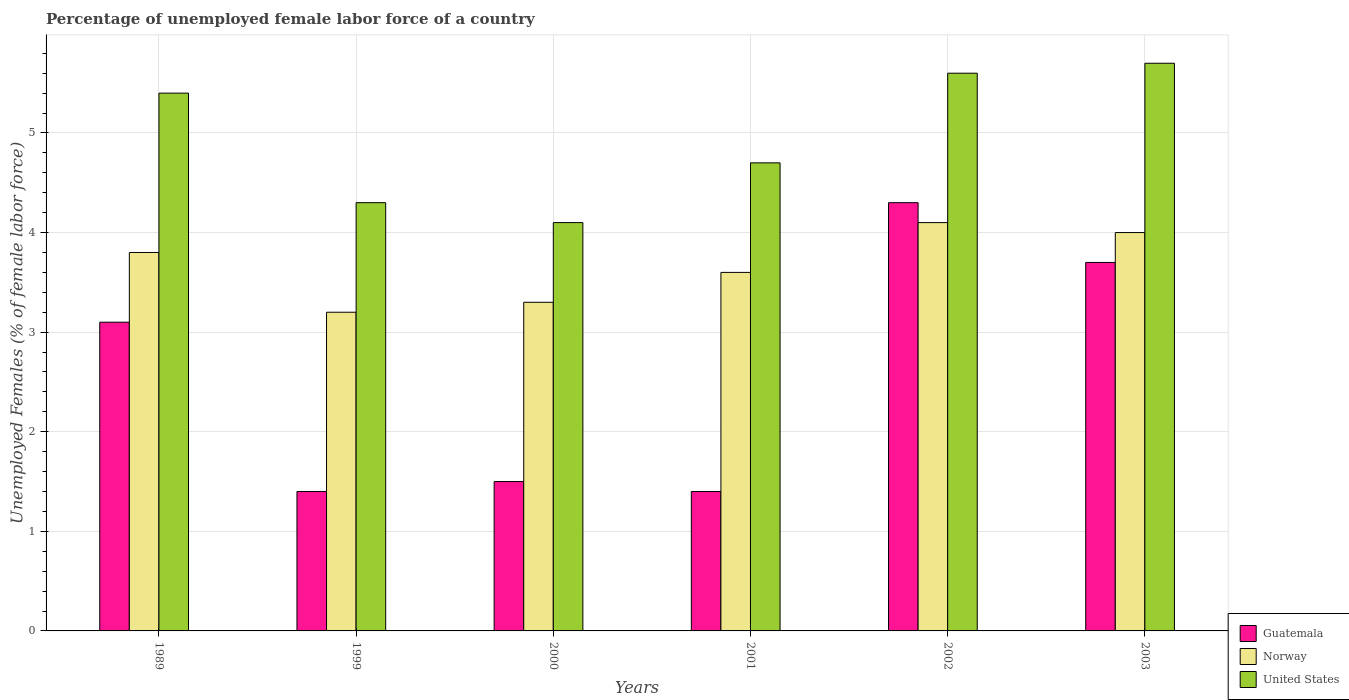How many different coloured bars are there?
Your response must be concise. 3. How many groups of bars are there?
Make the answer very short. 6. What is the percentage of unemployed female labor force in United States in 2003?
Ensure brevity in your answer.  5.7. Across all years, what is the maximum percentage of unemployed female labor force in United States?
Offer a terse response. 5.7. Across all years, what is the minimum percentage of unemployed female labor force in Guatemala?
Offer a very short reply. 1.4. In which year was the percentage of unemployed female labor force in Guatemala maximum?
Your response must be concise. 2002. What is the total percentage of unemployed female labor force in United States in the graph?
Ensure brevity in your answer.  29.8. What is the difference between the percentage of unemployed female labor force in Norway in 1989 and that in 2002?
Your response must be concise. -0.3. What is the difference between the percentage of unemployed female labor force in United States in 2001 and the percentage of unemployed female labor force in Guatemala in 1989?
Your answer should be compact. 1.6. What is the average percentage of unemployed female labor force in United States per year?
Provide a succinct answer. 4.97. In the year 1999, what is the difference between the percentage of unemployed female labor force in Norway and percentage of unemployed female labor force in United States?
Offer a terse response. -1.1. What is the ratio of the percentage of unemployed female labor force in Guatemala in 1989 to that in 2003?
Keep it short and to the point. 0.84. Is the difference between the percentage of unemployed female labor force in Norway in 2001 and 2002 greater than the difference between the percentage of unemployed female labor force in United States in 2001 and 2002?
Your answer should be very brief. Yes. What is the difference between the highest and the second highest percentage of unemployed female labor force in United States?
Make the answer very short. 0.1. What is the difference between the highest and the lowest percentage of unemployed female labor force in United States?
Offer a very short reply. 1.6. What does the 1st bar from the left in 2000 represents?
Offer a very short reply. Guatemala. What does the 3rd bar from the right in 1999 represents?
Provide a short and direct response. Guatemala. How many bars are there?
Keep it short and to the point. 18. Are all the bars in the graph horizontal?
Keep it short and to the point. No. How many years are there in the graph?
Keep it short and to the point. 6. What is the difference between two consecutive major ticks on the Y-axis?
Keep it short and to the point. 1. Does the graph contain grids?
Provide a short and direct response. Yes. Where does the legend appear in the graph?
Make the answer very short. Bottom right. How many legend labels are there?
Give a very brief answer. 3. What is the title of the graph?
Offer a very short reply. Percentage of unemployed female labor force of a country. What is the label or title of the Y-axis?
Give a very brief answer. Unemployed Females (% of female labor force). What is the Unemployed Females (% of female labor force) in Guatemala in 1989?
Provide a short and direct response. 3.1. What is the Unemployed Females (% of female labor force) in Norway in 1989?
Provide a short and direct response. 3.8. What is the Unemployed Females (% of female labor force) in United States in 1989?
Offer a very short reply. 5.4. What is the Unemployed Females (% of female labor force) of Guatemala in 1999?
Your response must be concise. 1.4. What is the Unemployed Females (% of female labor force) of Norway in 1999?
Provide a succinct answer. 3.2. What is the Unemployed Females (% of female labor force) of United States in 1999?
Keep it short and to the point. 4.3. What is the Unemployed Females (% of female labor force) in Guatemala in 2000?
Provide a short and direct response. 1.5. What is the Unemployed Females (% of female labor force) of Norway in 2000?
Your answer should be compact. 3.3. What is the Unemployed Females (% of female labor force) in United States in 2000?
Give a very brief answer. 4.1. What is the Unemployed Females (% of female labor force) of Guatemala in 2001?
Provide a short and direct response. 1.4. What is the Unemployed Females (% of female labor force) in Norway in 2001?
Your answer should be very brief. 3.6. What is the Unemployed Females (% of female labor force) of United States in 2001?
Your answer should be very brief. 4.7. What is the Unemployed Females (% of female labor force) of Guatemala in 2002?
Offer a very short reply. 4.3. What is the Unemployed Females (% of female labor force) of Norway in 2002?
Provide a succinct answer. 4.1. What is the Unemployed Females (% of female labor force) of United States in 2002?
Provide a succinct answer. 5.6. What is the Unemployed Females (% of female labor force) in Guatemala in 2003?
Your response must be concise. 3.7. What is the Unemployed Females (% of female labor force) of United States in 2003?
Offer a terse response. 5.7. Across all years, what is the maximum Unemployed Females (% of female labor force) in Guatemala?
Keep it short and to the point. 4.3. Across all years, what is the maximum Unemployed Females (% of female labor force) in Norway?
Provide a short and direct response. 4.1. Across all years, what is the maximum Unemployed Females (% of female labor force) of United States?
Give a very brief answer. 5.7. Across all years, what is the minimum Unemployed Females (% of female labor force) of Guatemala?
Give a very brief answer. 1.4. Across all years, what is the minimum Unemployed Females (% of female labor force) in Norway?
Your response must be concise. 3.2. Across all years, what is the minimum Unemployed Females (% of female labor force) of United States?
Ensure brevity in your answer.  4.1. What is the total Unemployed Females (% of female labor force) of Guatemala in the graph?
Give a very brief answer. 15.4. What is the total Unemployed Females (% of female labor force) of United States in the graph?
Keep it short and to the point. 29.8. What is the difference between the Unemployed Females (% of female labor force) of United States in 1989 and that in 1999?
Provide a succinct answer. 1.1. What is the difference between the Unemployed Females (% of female labor force) of Norway in 1989 and that in 2001?
Your response must be concise. 0.2. What is the difference between the Unemployed Females (% of female labor force) in United States in 1989 and that in 2001?
Offer a terse response. 0.7. What is the difference between the Unemployed Females (% of female labor force) in Guatemala in 1989 and that in 2002?
Your answer should be very brief. -1.2. What is the difference between the Unemployed Females (% of female labor force) of Norway in 1989 and that in 2002?
Offer a very short reply. -0.3. What is the difference between the Unemployed Females (% of female labor force) of Guatemala in 1989 and that in 2003?
Offer a terse response. -0.6. What is the difference between the Unemployed Females (% of female labor force) in Norway in 1989 and that in 2003?
Your answer should be compact. -0.2. What is the difference between the Unemployed Females (% of female labor force) in Norway in 1999 and that in 2001?
Your response must be concise. -0.4. What is the difference between the Unemployed Females (% of female labor force) in United States in 1999 and that in 2001?
Your response must be concise. -0.4. What is the difference between the Unemployed Females (% of female labor force) of Guatemala in 1999 and that in 2002?
Make the answer very short. -2.9. What is the difference between the Unemployed Females (% of female labor force) in Norway in 1999 and that in 2002?
Keep it short and to the point. -0.9. What is the difference between the Unemployed Females (% of female labor force) of Guatemala in 1999 and that in 2003?
Provide a succinct answer. -2.3. What is the difference between the Unemployed Females (% of female labor force) in United States in 2000 and that in 2001?
Keep it short and to the point. -0.6. What is the difference between the Unemployed Females (% of female labor force) of United States in 2000 and that in 2002?
Your response must be concise. -1.5. What is the difference between the Unemployed Females (% of female labor force) of Norway in 2000 and that in 2003?
Keep it short and to the point. -0.7. What is the difference between the Unemployed Females (% of female labor force) in Guatemala in 2001 and that in 2002?
Your answer should be compact. -2.9. What is the difference between the Unemployed Females (% of female labor force) of Guatemala in 2001 and that in 2003?
Give a very brief answer. -2.3. What is the difference between the Unemployed Females (% of female labor force) of Norway in 2001 and that in 2003?
Make the answer very short. -0.4. What is the difference between the Unemployed Females (% of female labor force) in United States in 2001 and that in 2003?
Ensure brevity in your answer.  -1. What is the difference between the Unemployed Females (% of female labor force) of Guatemala in 1989 and the Unemployed Females (% of female labor force) of Norway in 1999?
Offer a terse response. -0.1. What is the difference between the Unemployed Females (% of female labor force) in Guatemala in 1989 and the Unemployed Females (% of female labor force) in Norway in 2000?
Your response must be concise. -0.2. What is the difference between the Unemployed Females (% of female labor force) in Guatemala in 1989 and the Unemployed Females (% of female labor force) in Norway in 2001?
Your answer should be very brief. -0.5. What is the difference between the Unemployed Females (% of female labor force) of Guatemala in 1989 and the Unemployed Females (% of female labor force) of United States in 2001?
Offer a terse response. -1.6. What is the difference between the Unemployed Females (% of female labor force) in Norway in 1989 and the Unemployed Females (% of female labor force) in United States in 2001?
Your response must be concise. -0.9. What is the difference between the Unemployed Females (% of female labor force) of Guatemala in 1989 and the Unemployed Females (% of female labor force) of Norway in 2002?
Your response must be concise. -1. What is the difference between the Unemployed Females (% of female labor force) in Norway in 1989 and the Unemployed Females (% of female labor force) in United States in 2002?
Offer a terse response. -1.8. What is the difference between the Unemployed Females (% of female labor force) of Norway in 1989 and the Unemployed Females (% of female labor force) of United States in 2003?
Your answer should be very brief. -1.9. What is the difference between the Unemployed Females (% of female labor force) in Guatemala in 1999 and the Unemployed Females (% of female labor force) in Norway in 2002?
Your answer should be compact. -2.7. What is the difference between the Unemployed Females (% of female labor force) in Norway in 1999 and the Unemployed Females (% of female labor force) in United States in 2002?
Keep it short and to the point. -2.4. What is the difference between the Unemployed Females (% of female labor force) in Guatemala in 1999 and the Unemployed Females (% of female labor force) in United States in 2003?
Ensure brevity in your answer.  -4.3. What is the difference between the Unemployed Females (% of female labor force) of Norway in 1999 and the Unemployed Females (% of female labor force) of United States in 2003?
Provide a short and direct response. -2.5. What is the difference between the Unemployed Females (% of female labor force) in Guatemala in 2000 and the Unemployed Females (% of female labor force) in United States in 2001?
Your answer should be compact. -3.2. What is the difference between the Unemployed Females (% of female labor force) of Norway in 2000 and the Unemployed Females (% of female labor force) of United States in 2001?
Provide a succinct answer. -1.4. What is the difference between the Unemployed Females (% of female labor force) of Guatemala in 2000 and the Unemployed Females (% of female labor force) of Norway in 2002?
Provide a short and direct response. -2.6. What is the difference between the Unemployed Females (% of female labor force) in Norway in 2000 and the Unemployed Females (% of female labor force) in United States in 2003?
Make the answer very short. -2.4. What is the difference between the Unemployed Females (% of female labor force) of Guatemala in 2001 and the Unemployed Females (% of female labor force) of Norway in 2002?
Provide a succinct answer. -2.7. What is the difference between the Unemployed Females (% of female labor force) in Guatemala in 2001 and the Unemployed Females (% of female labor force) in United States in 2003?
Provide a short and direct response. -4.3. What is the difference between the Unemployed Females (% of female labor force) of Guatemala in 2002 and the Unemployed Females (% of female labor force) of United States in 2003?
Your answer should be compact. -1.4. What is the difference between the Unemployed Females (% of female labor force) of Norway in 2002 and the Unemployed Females (% of female labor force) of United States in 2003?
Offer a terse response. -1.6. What is the average Unemployed Females (% of female labor force) of Guatemala per year?
Make the answer very short. 2.57. What is the average Unemployed Females (% of female labor force) in Norway per year?
Offer a very short reply. 3.67. What is the average Unemployed Females (% of female labor force) of United States per year?
Your answer should be very brief. 4.97. In the year 1989, what is the difference between the Unemployed Females (% of female labor force) in Guatemala and Unemployed Females (% of female labor force) in Norway?
Your answer should be very brief. -0.7. In the year 1989, what is the difference between the Unemployed Females (% of female labor force) of Guatemala and Unemployed Females (% of female labor force) of United States?
Offer a terse response. -2.3. In the year 1989, what is the difference between the Unemployed Females (% of female labor force) in Norway and Unemployed Females (% of female labor force) in United States?
Your answer should be compact. -1.6. In the year 1999, what is the difference between the Unemployed Females (% of female labor force) in Norway and Unemployed Females (% of female labor force) in United States?
Offer a very short reply. -1.1. In the year 2000, what is the difference between the Unemployed Females (% of female labor force) in Guatemala and Unemployed Females (% of female labor force) in Norway?
Your answer should be very brief. -1.8. In the year 2000, what is the difference between the Unemployed Females (% of female labor force) of Guatemala and Unemployed Females (% of female labor force) of United States?
Offer a very short reply. -2.6. In the year 2001, what is the difference between the Unemployed Females (% of female labor force) of Guatemala and Unemployed Females (% of female labor force) of Norway?
Your answer should be very brief. -2.2. In the year 2001, what is the difference between the Unemployed Females (% of female labor force) in Guatemala and Unemployed Females (% of female labor force) in United States?
Offer a very short reply. -3.3. In the year 2001, what is the difference between the Unemployed Females (% of female labor force) in Norway and Unemployed Females (% of female labor force) in United States?
Provide a succinct answer. -1.1. In the year 2002, what is the difference between the Unemployed Females (% of female labor force) in Guatemala and Unemployed Females (% of female labor force) in United States?
Make the answer very short. -1.3. What is the ratio of the Unemployed Females (% of female labor force) of Guatemala in 1989 to that in 1999?
Provide a succinct answer. 2.21. What is the ratio of the Unemployed Females (% of female labor force) of Norway in 1989 to that in 1999?
Offer a terse response. 1.19. What is the ratio of the Unemployed Females (% of female labor force) of United States in 1989 to that in 1999?
Make the answer very short. 1.26. What is the ratio of the Unemployed Females (% of female labor force) in Guatemala in 1989 to that in 2000?
Offer a terse response. 2.07. What is the ratio of the Unemployed Females (% of female labor force) in Norway in 1989 to that in 2000?
Your response must be concise. 1.15. What is the ratio of the Unemployed Females (% of female labor force) of United States in 1989 to that in 2000?
Give a very brief answer. 1.32. What is the ratio of the Unemployed Females (% of female labor force) of Guatemala in 1989 to that in 2001?
Your answer should be very brief. 2.21. What is the ratio of the Unemployed Females (% of female labor force) of Norway in 1989 to that in 2001?
Offer a terse response. 1.06. What is the ratio of the Unemployed Females (% of female labor force) of United States in 1989 to that in 2001?
Provide a short and direct response. 1.15. What is the ratio of the Unemployed Females (% of female labor force) in Guatemala in 1989 to that in 2002?
Give a very brief answer. 0.72. What is the ratio of the Unemployed Females (% of female labor force) of Norway in 1989 to that in 2002?
Your answer should be very brief. 0.93. What is the ratio of the Unemployed Females (% of female labor force) in Guatemala in 1989 to that in 2003?
Provide a short and direct response. 0.84. What is the ratio of the Unemployed Females (% of female labor force) of Norway in 1989 to that in 2003?
Ensure brevity in your answer.  0.95. What is the ratio of the Unemployed Females (% of female labor force) of Norway in 1999 to that in 2000?
Make the answer very short. 0.97. What is the ratio of the Unemployed Females (% of female labor force) of United States in 1999 to that in 2000?
Your response must be concise. 1.05. What is the ratio of the Unemployed Females (% of female labor force) in Guatemala in 1999 to that in 2001?
Offer a very short reply. 1. What is the ratio of the Unemployed Females (% of female labor force) in Norway in 1999 to that in 2001?
Offer a terse response. 0.89. What is the ratio of the Unemployed Females (% of female labor force) in United States in 1999 to that in 2001?
Keep it short and to the point. 0.91. What is the ratio of the Unemployed Females (% of female labor force) in Guatemala in 1999 to that in 2002?
Keep it short and to the point. 0.33. What is the ratio of the Unemployed Females (% of female labor force) in Norway in 1999 to that in 2002?
Keep it short and to the point. 0.78. What is the ratio of the Unemployed Females (% of female labor force) of United States in 1999 to that in 2002?
Your answer should be very brief. 0.77. What is the ratio of the Unemployed Females (% of female labor force) of Guatemala in 1999 to that in 2003?
Your answer should be compact. 0.38. What is the ratio of the Unemployed Females (% of female labor force) in Norway in 1999 to that in 2003?
Ensure brevity in your answer.  0.8. What is the ratio of the Unemployed Females (% of female labor force) in United States in 1999 to that in 2003?
Make the answer very short. 0.75. What is the ratio of the Unemployed Females (% of female labor force) of Guatemala in 2000 to that in 2001?
Make the answer very short. 1.07. What is the ratio of the Unemployed Females (% of female labor force) in United States in 2000 to that in 2001?
Your response must be concise. 0.87. What is the ratio of the Unemployed Females (% of female labor force) in Guatemala in 2000 to that in 2002?
Ensure brevity in your answer.  0.35. What is the ratio of the Unemployed Females (% of female labor force) in Norway in 2000 to that in 2002?
Offer a terse response. 0.8. What is the ratio of the Unemployed Females (% of female labor force) of United States in 2000 to that in 2002?
Offer a terse response. 0.73. What is the ratio of the Unemployed Females (% of female labor force) in Guatemala in 2000 to that in 2003?
Give a very brief answer. 0.41. What is the ratio of the Unemployed Females (% of female labor force) in Norway in 2000 to that in 2003?
Provide a short and direct response. 0.82. What is the ratio of the Unemployed Females (% of female labor force) in United States in 2000 to that in 2003?
Your response must be concise. 0.72. What is the ratio of the Unemployed Females (% of female labor force) of Guatemala in 2001 to that in 2002?
Give a very brief answer. 0.33. What is the ratio of the Unemployed Females (% of female labor force) in Norway in 2001 to that in 2002?
Provide a succinct answer. 0.88. What is the ratio of the Unemployed Females (% of female labor force) of United States in 2001 to that in 2002?
Make the answer very short. 0.84. What is the ratio of the Unemployed Females (% of female labor force) in Guatemala in 2001 to that in 2003?
Give a very brief answer. 0.38. What is the ratio of the Unemployed Females (% of female labor force) of Norway in 2001 to that in 2003?
Make the answer very short. 0.9. What is the ratio of the Unemployed Females (% of female labor force) of United States in 2001 to that in 2003?
Provide a succinct answer. 0.82. What is the ratio of the Unemployed Females (% of female labor force) of Guatemala in 2002 to that in 2003?
Provide a short and direct response. 1.16. What is the ratio of the Unemployed Females (% of female labor force) in United States in 2002 to that in 2003?
Offer a terse response. 0.98. What is the difference between the highest and the second highest Unemployed Females (% of female labor force) of Guatemala?
Keep it short and to the point. 0.6. What is the difference between the highest and the lowest Unemployed Females (% of female labor force) of Norway?
Make the answer very short. 0.9. 